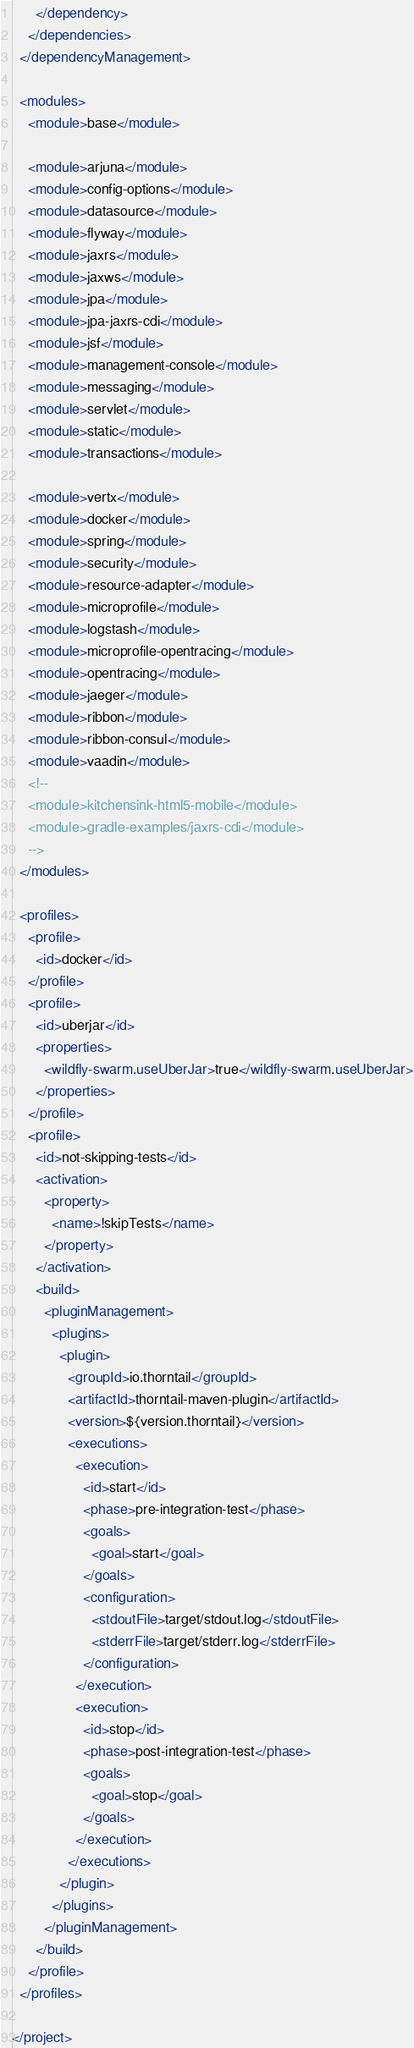Convert code to text. <code><loc_0><loc_0><loc_500><loc_500><_XML_>      </dependency>
    </dependencies>
  </dependencyManagement>

  <modules>
    <module>base</module>

    <module>arjuna</module>
    <module>config-options</module>
    <module>datasource</module>
    <module>flyway</module>
    <module>jaxrs</module>
    <module>jaxws</module>
    <module>jpa</module>
    <module>jpa-jaxrs-cdi</module>
    <module>jsf</module>
    <module>management-console</module>
    <module>messaging</module>
    <module>servlet</module>
    <module>static</module>
    <module>transactions</module>

    <module>vertx</module>
    <module>docker</module>
    <module>spring</module>
    <module>security</module>
    <module>resource-adapter</module>
    <module>microprofile</module>
    <module>logstash</module>
    <module>microprofile-opentracing</module>
    <module>opentracing</module>
    <module>jaeger</module>
    <module>ribbon</module>
    <module>ribbon-consul</module>
    <module>vaadin</module>
    <!--
    <module>kitchensink-html5-mobile</module>
    <module>gradle-examples/jaxrs-cdi</module>
    -->
  </modules>

  <profiles>
    <profile>
      <id>docker</id>
    </profile>
    <profile>
      <id>uberjar</id>
      <properties>
        <wildfly-swarm.useUberJar>true</wildfly-swarm.useUberJar>
      </properties>
    </profile>
    <profile>
      <id>not-skipping-tests</id>
      <activation>
        <property>
          <name>!skipTests</name>
        </property>
      </activation>
      <build>
        <pluginManagement>
          <plugins>
            <plugin>
              <groupId>io.thorntail</groupId>
              <artifactId>thorntail-maven-plugin</artifactId>
              <version>${version.thorntail}</version>
              <executions>
                <execution>
                  <id>start</id>
                  <phase>pre-integration-test</phase>
                  <goals>
                    <goal>start</goal>
                  </goals>
                  <configuration>
                    <stdoutFile>target/stdout.log</stdoutFile>
                    <stderrFile>target/stderr.log</stderrFile>
                  </configuration>
                </execution>
                <execution>
                  <id>stop</id>
                  <phase>post-integration-test</phase>
                  <goals>
                    <goal>stop</goal>
                  </goals>
                </execution>
              </executions>
            </plugin>
          </plugins>
        </pluginManagement>
      </build>
    </profile>
  </profiles>

</project>
</code> 